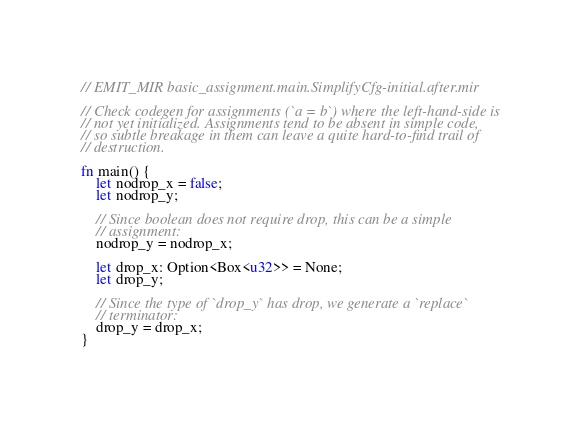Convert code to text. <code><loc_0><loc_0><loc_500><loc_500><_Rust_>// EMIT_MIR basic_assignment.main.SimplifyCfg-initial.after.mir

// Check codegen for assignments (`a = b`) where the left-hand-side is
// not yet initialized. Assignments tend to be absent in simple code,
// so subtle breakage in them can leave a quite hard-to-find trail of
// destruction.

fn main() {
    let nodrop_x = false;
    let nodrop_y;

    // Since boolean does not require drop, this can be a simple
    // assignment:
    nodrop_y = nodrop_x;

    let drop_x: Option<Box<u32>> = None;
    let drop_y;

    // Since the type of `drop_y` has drop, we generate a `replace`
    // terminator:
    drop_y = drop_x;
}
</code> 